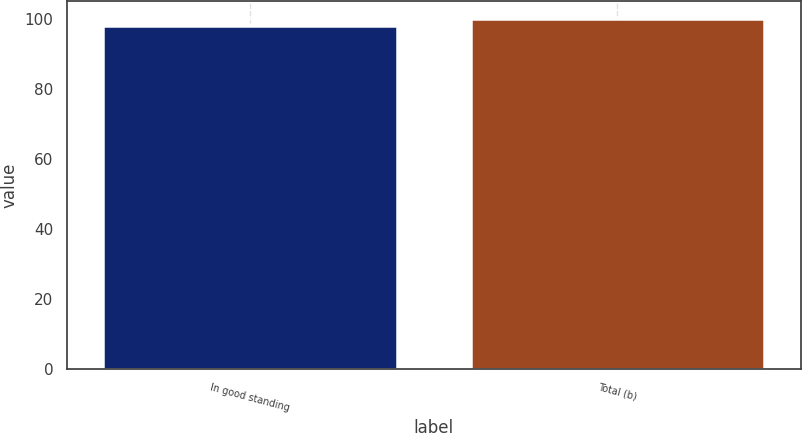Convert chart. <chart><loc_0><loc_0><loc_500><loc_500><bar_chart><fcel>In good standing<fcel>Total (b)<nl><fcel>98<fcel>100<nl></chart> 